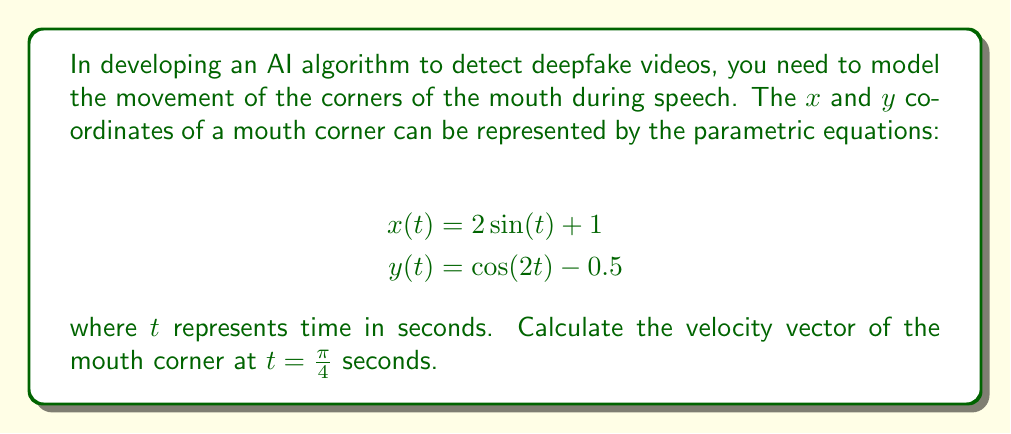Provide a solution to this math problem. To find the velocity vector at a specific time, we need to calculate the derivatives of both $x(t)$ and $y(t)$ with respect to $t$, and then evaluate them at the given time.

1. First, let's find $\frac{dx}{dt}$ and $\frac{dy}{dt}$:

   $$\frac{dx}{dt} = 2 \cos(t)$$
   $$\frac{dy}{dt} = -2 \sin(2t)$$

2. The velocity vector is given by $\vec{v}(t) = \left(\frac{dx}{dt}, \frac{dy}{dt}\right)$.

3. Now, we need to evaluate these at $t = \frac{\pi}{4}$:

   $$\frac{dx}{dt}\bigg|_{t=\frac{\pi}{4}} = 2 \cos(\frac{\pi}{4}) = 2 \cdot \frac{\sqrt{2}}{2} = \sqrt{2}$$

   $$\frac{dy}{dt}\bigg|_{t=\frac{\pi}{4}} = -2 \sin(2 \cdot \frac{\pi}{4}) = -2 \sin(\frac{\pi}{2}) = -2$$

4. Therefore, the velocity vector at $t = \frac{\pi}{4}$ is:

   $$\vec{v}(\frac{\pi}{4}) = (\sqrt{2}, -2)$$

This vector represents the instantaneous velocity of the mouth corner at $t = \frac{\pi}{4}$ seconds.
Answer: The velocity vector of the mouth corner at $t = \frac{\pi}{4}$ seconds is $(\sqrt{2}, -2)$. 